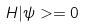Convert formula to latex. <formula><loc_0><loc_0><loc_500><loc_500>H | \psi > = 0</formula> 